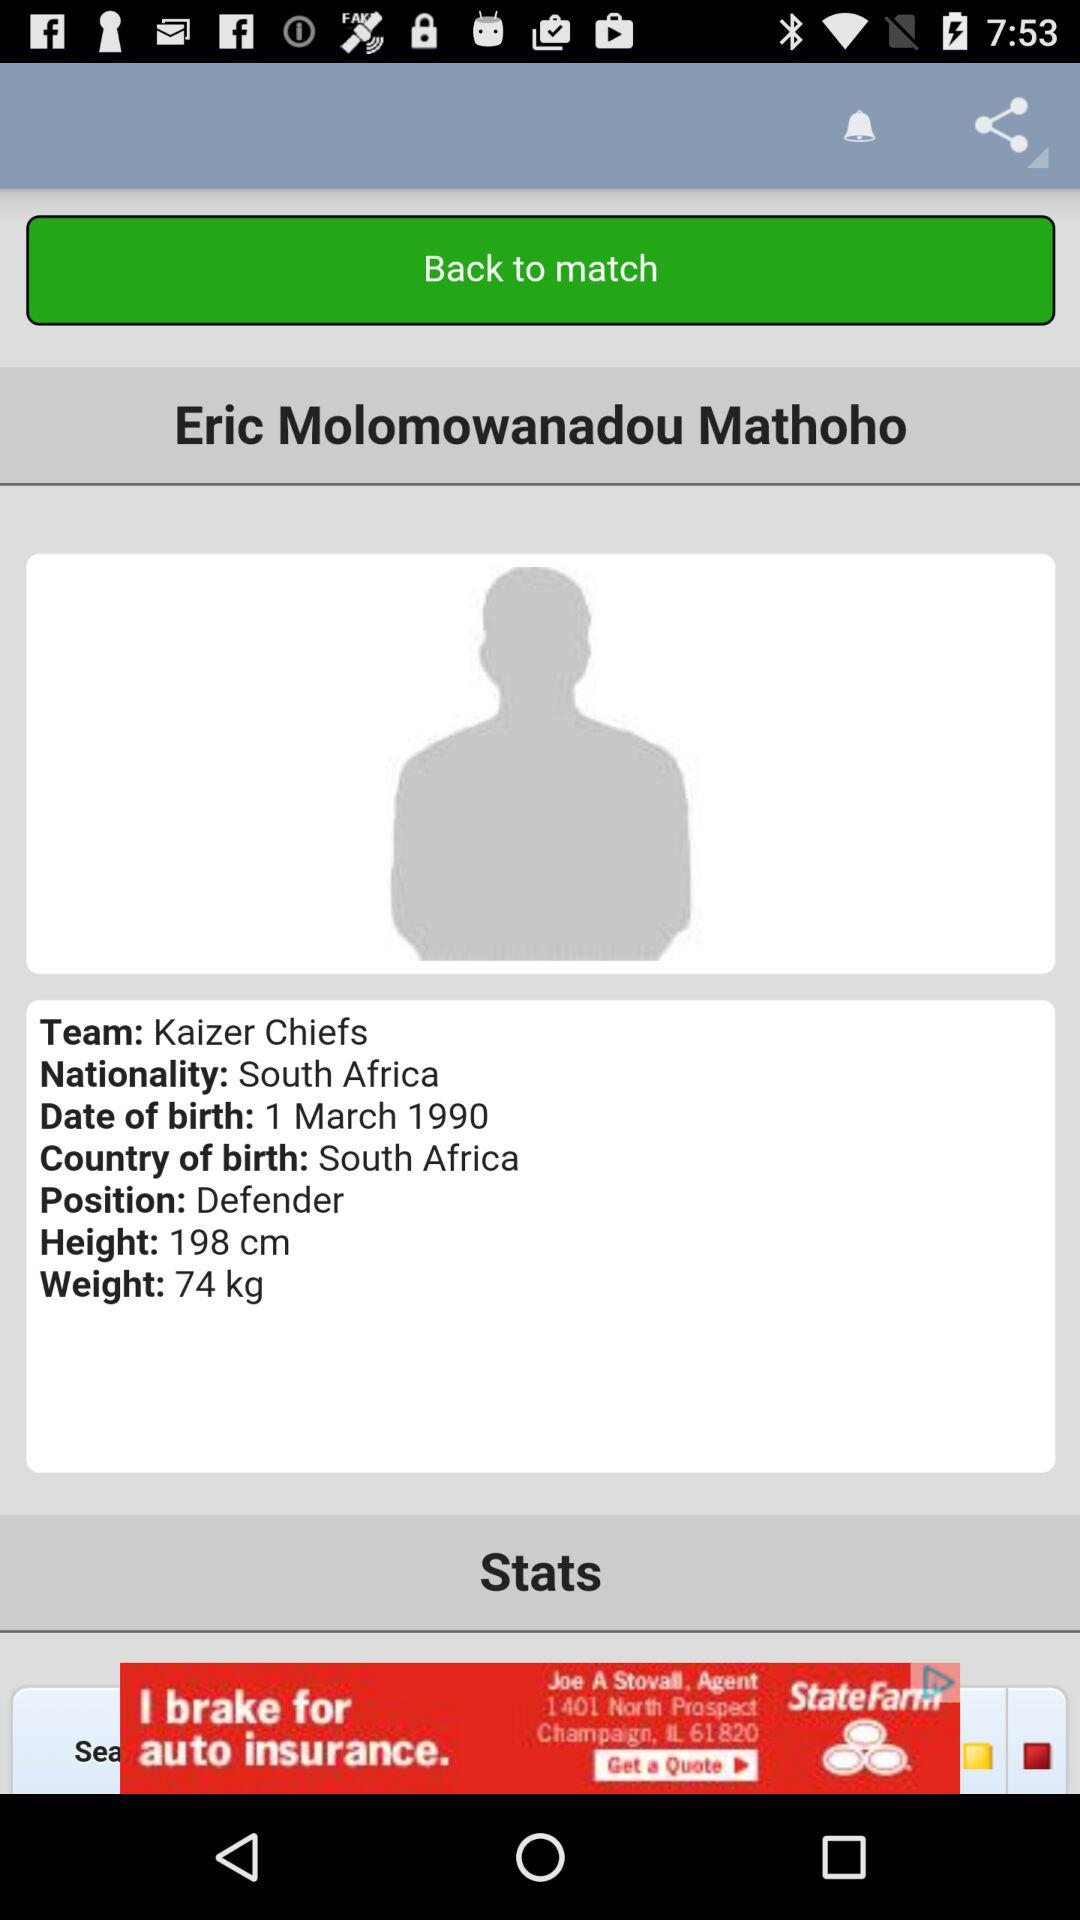Which sport does the user play?
When the provided information is insufficient, respond with <no answer>. <no answer> 